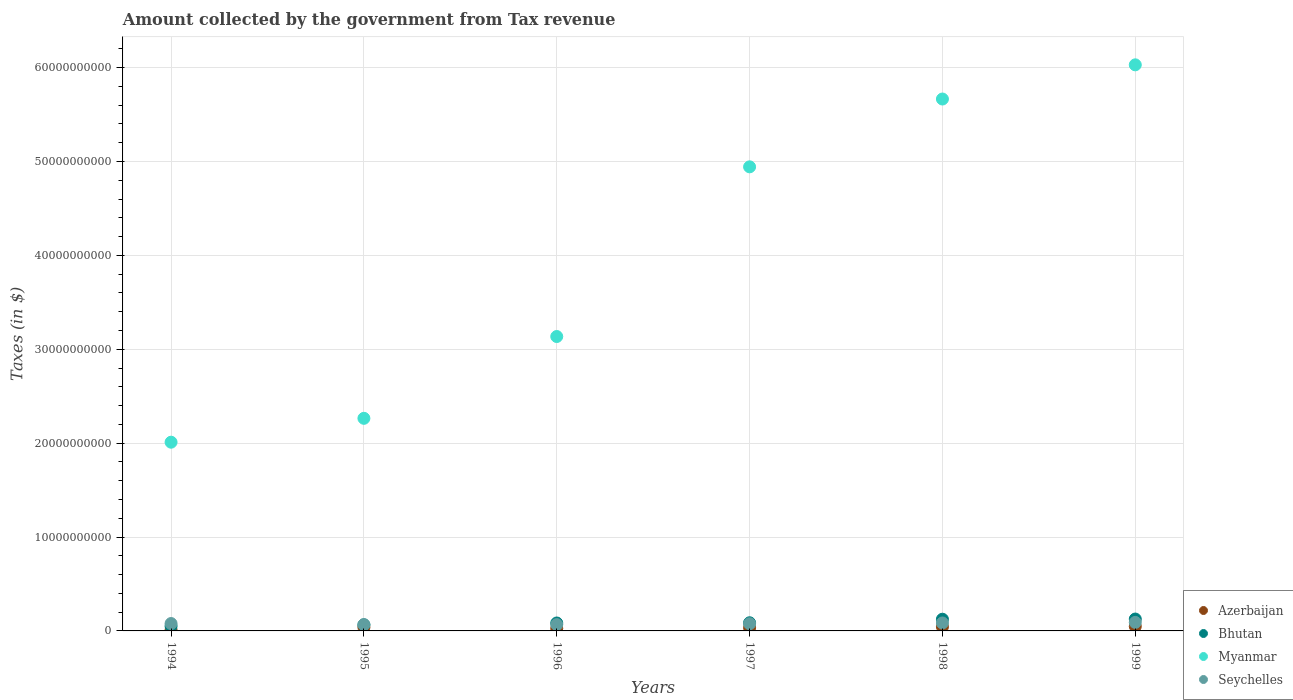What is the amount collected by the government from tax revenue in Bhutan in 1994?
Provide a succinct answer. 5.03e+08. Across all years, what is the maximum amount collected by the government from tax revenue in Bhutan?
Ensure brevity in your answer.  1.27e+09. Across all years, what is the minimum amount collected by the government from tax revenue in Bhutan?
Make the answer very short. 5.03e+08. What is the total amount collected by the government from tax revenue in Azerbaijan in the graph?
Offer a very short reply. 2.00e+09. What is the difference between the amount collected by the government from tax revenue in Myanmar in 1994 and that in 1999?
Keep it short and to the point. -4.02e+1. What is the difference between the amount collected by the government from tax revenue in Bhutan in 1997 and the amount collected by the government from tax revenue in Azerbaijan in 1999?
Provide a succinct answer. 3.88e+08. What is the average amount collected by the government from tax revenue in Myanmar per year?
Ensure brevity in your answer.  4.01e+1. In the year 1997, what is the difference between the amount collected by the government from tax revenue in Azerbaijan and amount collected by the government from tax revenue in Myanmar?
Provide a short and direct response. -4.91e+1. In how many years, is the amount collected by the government from tax revenue in Seychelles greater than 46000000000 $?
Your answer should be compact. 0. What is the ratio of the amount collected by the government from tax revenue in Myanmar in 1994 to that in 1998?
Make the answer very short. 0.35. Is the difference between the amount collected by the government from tax revenue in Azerbaijan in 1995 and 1998 greater than the difference between the amount collected by the government from tax revenue in Myanmar in 1995 and 1998?
Your answer should be compact. Yes. What is the difference between the highest and the second highest amount collected by the government from tax revenue in Myanmar?
Provide a succinct answer. 3.64e+09. What is the difference between the highest and the lowest amount collected by the government from tax revenue in Bhutan?
Offer a terse response. 7.62e+08. In how many years, is the amount collected by the government from tax revenue in Bhutan greater than the average amount collected by the government from tax revenue in Bhutan taken over all years?
Keep it short and to the point. 2. Is it the case that in every year, the sum of the amount collected by the government from tax revenue in Myanmar and amount collected by the government from tax revenue in Azerbaijan  is greater than the sum of amount collected by the government from tax revenue in Bhutan and amount collected by the government from tax revenue in Seychelles?
Make the answer very short. No. Is it the case that in every year, the sum of the amount collected by the government from tax revenue in Azerbaijan and amount collected by the government from tax revenue in Myanmar  is greater than the amount collected by the government from tax revenue in Seychelles?
Provide a succinct answer. Yes. Does the amount collected by the government from tax revenue in Azerbaijan monotonically increase over the years?
Offer a very short reply. No. Is the amount collected by the government from tax revenue in Myanmar strictly less than the amount collected by the government from tax revenue in Bhutan over the years?
Make the answer very short. No. How many years are there in the graph?
Offer a very short reply. 6. Does the graph contain grids?
Keep it short and to the point. Yes. Where does the legend appear in the graph?
Offer a very short reply. Bottom right. How many legend labels are there?
Offer a terse response. 4. How are the legend labels stacked?
Give a very brief answer. Vertical. What is the title of the graph?
Make the answer very short. Amount collected by the government from Tax revenue. What is the label or title of the X-axis?
Offer a very short reply. Years. What is the label or title of the Y-axis?
Provide a short and direct response. Taxes (in $). What is the Taxes (in $) of Azerbaijan in 1994?
Provide a short and direct response. 9.58e+07. What is the Taxes (in $) in Bhutan in 1994?
Make the answer very short. 5.03e+08. What is the Taxes (in $) in Myanmar in 1994?
Ensure brevity in your answer.  2.01e+1. What is the Taxes (in $) in Seychelles in 1994?
Give a very brief answer. 7.86e+08. What is the Taxes (in $) of Azerbaijan in 1995?
Offer a terse response. 3.83e+08. What is the Taxes (in $) of Bhutan in 1995?
Your response must be concise. 6.50e+08. What is the Taxes (in $) in Myanmar in 1995?
Ensure brevity in your answer.  2.26e+1. What is the Taxes (in $) in Seychelles in 1995?
Offer a terse response. 6.69e+08. What is the Taxes (in $) in Azerbaijan in 1996?
Make the answer very short. 2.69e+08. What is the Taxes (in $) in Bhutan in 1996?
Make the answer very short. 8.44e+08. What is the Taxes (in $) of Myanmar in 1996?
Your response must be concise. 3.14e+1. What is the Taxes (in $) in Seychelles in 1996?
Offer a terse response. 6.74e+08. What is the Taxes (in $) of Azerbaijan in 1997?
Make the answer very short. 3.38e+08. What is the Taxes (in $) of Bhutan in 1997?
Your answer should be compact. 8.69e+08. What is the Taxes (in $) in Myanmar in 1997?
Make the answer very short. 4.94e+1. What is the Taxes (in $) of Seychelles in 1997?
Make the answer very short. 7.63e+08. What is the Taxes (in $) in Azerbaijan in 1998?
Offer a terse response. 4.36e+08. What is the Taxes (in $) of Bhutan in 1998?
Provide a short and direct response. 1.25e+09. What is the Taxes (in $) of Myanmar in 1998?
Provide a succinct answer. 5.67e+1. What is the Taxes (in $) of Seychelles in 1998?
Your response must be concise. 8.46e+08. What is the Taxes (in $) of Azerbaijan in 1999?
Keep it short and to the point. 4.81e+08. What is the Taxes (in $) of Bhutan in 1999?
Make the answer very short. 1.27e+09. What is the Taxes (in $) in Myanmar in 1999?
Offer a terse response. 6.03e+1. What is the Taxes (in $) of Seychelles in 1999?
Provide a short and direct response. 9.06e+08. Across all years, what is the maximum Taxes (in $) in Azerbaijan?
Keep it short and to the point. 4.81e+08. Across all years, what is the maximum Taxes (in $) in Bhutan?
Your answer should be very brief. 1.27e+09. Across all years, what is the maximum Taxes (in $) in Myanmar?
Keep it short and to the point. 6.03e+1. Across all years, what is the maximum Taxes (in $) in Seychelles?
Your answer should be compact. 9.06e+08. Across all years, what is the minimum Taxes (in $) of Azerbaijan?
Ensure brevity in your answer.  9.58e+07. Across all years, what is the minimum Taxes (in $) in Bhutan?
Offer a very short reply. 5.03e+08. Across all years, what is the minimum Taxes (in $) in Myanmar?
Your answer should be very brief. 2.01e+1. Across all years, what is the minimum Taxes (in $) of Seychelles?
Ensure brevity in your answer.  6.69e+08. What is the total Taxes (in $) in Azerbaijan in the graph?
Keep it short and to the point. 2.00e+09. What is the total Taxes (in $) in Bhutan in the graph?
Make the answer very short. 5.38e+09. What is the total Taxes (in $) in Myanmar in the graph?
Your response must be concise. 2.40e+11. What is the total Taxes (in $) of Seychelles in the graph?
Provide a short and direct response. 4.64e+09. What is the difference between the Taxes (in $) of Azerbaijan in 1994 and that in 1995?
Offer a very short reply. -2.87e+08. What is the difference between the Taxes (in $) in Bhutan in 1994 and that in 1995?
Make the answer very short. -1.46e+08. What is the difference between the Taxes (in $) of Myanmar in 1994 and that in 1995?
Your answer should be very brief. -2.54e+09. What is the difference between the Taxes (in $) in Seychelles in 1994 and that in 1995?
Make the answer very short. 1.17e+08. What is the difference between the Taxes (in $) in Azerbaijan in 1994 and that in 1996?
Keep it short and to the point. -1.73e+08. What is the difference between the Taxes (in $) in Bhutan in 1994 and that in 1996?
Make the answer very short. -3.41e+08. What is the difference between the Taxes (in $) of Myanmar in 1994 and that in 1996?
Provide a short and direct response. -1.13e+1. What is the difference between the Taxes (in $) of Seychelles in 1994 and that in 1996?
Ensure brevity in your answer.  1.13e+08. What is the difference between the Taxes (in $) of Azerbaijan in 1994 and that in 1997?
Your answer should be compact. -2.42e+08. What is the difference between the Taxes (in $) in Bhutan in 1994 and that in 1997?
Provide a succinct answer. -3.66e+08. What is the difference between the Taxes (in $) in Myanmar in 1994 and that in 1997?
Your answer should be very brief. -2.93e+1. What is the difference between the Taxes (in $) in Seychelles in 1994 and that in 1997?
Provide a succinct answer. 2.32e+07. What is the difference between the Taxes (in $) of Azerbaijan in 1994 and that in 1998?
Make the answer very short. -3.40e+08. What is the difference between the Taxes (in $) of Bhutan in 1994 and that in 1998?
Your answer should be compact. -7.43e+08. What is the difference between the Taxes (in $) of Myanmar in 1994 and that in 1998?
Offer a terse response. -3.66e+1. What is the difference between the Taxes (in $) in Seychelles in 1994 and that in 1998?
Your response must be concise. -6.01e+07. What is the difference between the Taxes (in $) in Azerbaijan in 1994 and that in 1999?
Ensure brevity in your answer.  -3.85e+08. What is the difference between the Taxes (in $) in Bhutan in 1994 and that in 1999?
Your answer should be compact. -7.62e+08. What is the difference between the Taxes (in $) of Myanmar in 1994 and that in 1999?
Ensure brevity in your answer.  -4.02e+1. What is the difference between the Taxes (in $) in Seychelles in 1994 and that in 1999?
Your response must be concise. -1.20e+08. What is the difference between the Taxes (in $) in Azerbaijan in 1995 and that in 1996?
Your answer should be compact. 1.14e+08. What is the difference between the Taxes (in $) of Bhutan in 1995 and that in 1996?
Your answer should be very brief. -1.94e+08. What is the difference between the Taxes (in $) of Myanmar in 1995 and that in 1996?
Offer a very short reply. -8.71e+09. What is the difference between the Taxes (in $) in Seychelles in 1995 and that in 1996?
Your answer should be compact. -4.70e+06. What is the difference between the Taxes (in $) of Azerbaijan in 1995 and that in 1997?
Provide a short and direct response. 4.54e+07. What is the difference between the Taxes (in $) in Bhutan in 1995 and that in 1997?
Your response must be concise. -2.19e+08. What is the difference between the Taxes (in $) of Myanmar in 1995 and that in 1997?
Offer a terse response. -2.68e+1. What is the difference between the Taxes (in $) in Seychelles in 1995 and that in 1997?
Make the answer very short. -9.42e+07. What is the difference between the Taxes (in $) of Azerbaijan in 1995 and that in 1998?
Give a very brief answer. -5.31e+07. What is the difference between the Taxes (in $) of Bhutan in 1995 and that in 1998?
Make the answer very short. -5.97e+08. What is the difference between the Taxes (in $) in Myanmar in 1995 and that in 1998?
Give a very brief answer. -3.40e+1. What is the difference between the Taxes (in $) of Seychelles in 1995 and that in 1998?
Your answer should be very brief. -1.78e+08. What is the difference between the Taxes (in $) in Azerbaijan in 1995 and that in 1999?
Your answer should be compact. -9.76e+07. What is the difference between the Taxes (in $) in Bhutan in 1995 and that in 1999?
Your answer should be compact. -6.16e+08. What is the difference between the Taxes (in $) in Myanmar in 1995 and that in 1999?
Make the answer very short. -3.76e+1. What is the difference between the Taxes (in $) in Seychelles in 1995 and that in 1999?
Make the answer very short. -2.37e+08. What is the difference between the Taxes (in $) of Azerbaijan in 1996 and that in 1997?
Offer a terse response. -6.86e+07. What is the difference between the Taxes (in $) in Bhutan in 1996 and that in 1997?
Make the answer very short. -2.47e+07. What is the difference between the Taxes (in $) of Myanmar in 1996 and that in 1997?
Ensure brevity in your answer.  -1.81e+1. What is the difference between the Taxes (in $) of Seychelles in 1996 and that in 1997?
Keep it short and to the point. -8.95e+07. What is the difference between the Taxes (in $) of Azerbaijan in 1996 and that in 1998?
Your answer should be very brief. -1.67e+08. What is the difference between the Taxes (in $) in Bhutan in 1996 and that in 1998?
Your answer should be very brief. -4.02e+08. What is the difference between the Taxes (in $) of Myanmar in 1996 and that in 1998?
Your answer should be very brief. -2.53e+1. What is the difference between the Taxes (in $) of Seychelles in 1996 and that in 1998?
Provide a succinct answer. -1.73e+08. What is the difference between the Taxes (in $) in Azerbaijan in 1996 and that in 1999?
Ensure brevity in your answer.  -2.12e+08. What is the difference between the Taxes (in $) of Bhutan in 1996 and that in 1999?
Ensure brevity in your answer.  -4.22e+08. What is the difference between the Taxes (in $) in Myanmar in 1996 and that in 1999?
Your response must be concise. -2.89e+1. What is the difference between the Taxes (in $) of Seychelles in 1996 and that in 1999?
Provide a succinct answer. -2.32e+08. What is the difference between the Taxes (in $) in Azerbaijan in 1997 and that in 1998?
Provide a succinct answer. -9.85e+07. What is the difference between the Taxes (in $) of Bhutan in 1997 and that in 1998?
Provide a succinct answer. -3.77e+08. What is the difference between the Taxes (in $) of Myanmar in 1997 and that in 1998?
Your answer should be compact. -7.22e+09. What is the difference between the Taxes (in $) of Seychelles in 1997 and that in 1998?
Ensure brevity in your answer.  -8.33e+07. What is the difference between the Taxes (in $) in Azerbaijan in 1997 and that in 1999?
Provide a short and direct response. -1.43e+08. What is the difference between the Taxes (in $) of Bhutan in 1997 and that in 1999?
Ensure brevity in your answer.  -3.97e+08. What is the difference between the Taxes (in $) of Myanmar in 1997 and that in 1999?
Provide a succinct answer. -1.09e+1. What is the difference between the Taxes (in $) of Seychelles in 1997 and that in 1999?
Provide a succinct answer. -1.43e+08. What is the difference between the Taxes (in $) in Azerbaijan in 1998 and that in 1999?
Ensure brevity in your answer.  -4.45e+07. What is the difference between the Taxes (in $) in Bhutan in 1998 and that in 1999?
Your answer should be compact. -1.94e+07. What is the difference between the Taxes (in $) in Myanmar in 1998 and that in 1999?
Make the answer very short. -3.64e+09. What is the difference between the Taxes (in $) of Seychelles in 1998 and that in 1999?
Provide a succinct answer. -5.96e+07. What is the difference between the Taxes (in $) in Azerbaijan in 1994 and the Taxes (in $) in Bhutan in 1995?
Your answer should be compact. -5.54e+08. What is the difference between the Taxes (in $) in Azerbaijan in 1994 and the Taxes (in $) in Myanmar in 1995?
Offer a terse response. -2.25e+1. What is the difference between the Taxes (in $) in Azerbaijan in 1994 and the Taxes (in $) in Seychelles in 1995?
Give a very brief answer. -5.73e+08. What is the difference between the Taxes (in $) in Bhutan in 1994 and the Taxes (in $) in Myanmar in 1995?
Your response must be concise. -2.21e+1. What is the difference between the Taxes (in $) of Bhutan in 1994 and the Taxes (in $) of Seychelles in 1995?
Offer a very short reply. -1.66e+08. What is the difference between the Taxes (in $) in Myanmar in 1994 and the Taxes (in $) in Seychelles in 1995?
Your response must be concise. 1.94e+1. What is the difference between the Taxes (in $) of Azerbaijan in 1994 and the Taxes (in $) of Bhutan in 1996?
Your answer should be compact. -7.48e+08. What is the difference between the Taxes (in $) in Azerbaijan in 1994 and the Taxes (in $) in Myanmar in 1996?
Offer a terse response. -3.13e+1. What is the difference between the Taxes (in $) in Azerbaijan in 1994 and the Taxes (in $) in Seychelles in 1996?
Provide a succinct answer. -5.78e+08. What is the difference between the Taxes (in $) in Bhutan in 1994 and the Taxes (in $) in Myanmar in 1996?
Offer a very short reply. -3.09e+1. What is the difference between the Taxes (in $) of Bhutan in 1994 and the Taxes (in $) of Seychelles in 1996?
Provide a succinct answer. -1.70e+08. What is the difference between the Taxes (in $) of Myanmar in 1994 and the Taxes (in $) of Seychelles in 1996?
Keep it short and to the point. 1.94e+1. What is the difference between the Taxes (in $) in Azerbaijan in 1994 and the Taxes (in $) in Bhutan in 1997?
Provide a short and direct response. -7.73e+08. What is the difference between the Taxes (in $) of Azerbaijan in 1994 and the Taxes (in $) of Myanmar in 1997?
Keep it short and to the point. -4.93e+1. What is the difference between the Taxes (in $) of Azerbaijan in 1994 and the Taxes (in $) of Seychelles in 1997?
Your answer should be very brief. -6.67e+08. What is the difference between the Taxes (in $) in Bhutan in 1994 and the Taxes (in $) in Myanmar in 1997?
Your answer should be compact. -4.89e+1. What is the difference between the Taxes (in $) of Bhutan in 1994 and the Taxes (in $) of Seychelles in 1997?
Provide a succinct answer. -2.60e+08. What is the difference between the Taxes (in $) in Myanmar in 1994 and the Taxes (in $) in Seychelles in 1997?
Ensure brevity in your answer.  1.93e+1. What is the difference between the Taxes (in $) in Azerbaijan in 1994 and the Taxes (in $) in Bhutan in 1998?
Your answer should be very brief. -1.15e+09. What is the difference between the Taxes (in $) of Azerbaijan in 1994 and the Taxes (in $) of Myanmar in 1998?
Give a very brief answer. -5.66e+1. What is the difference between the Taxes (in $) of Azerbaijan in 1994 and the Taxes (in $) of Seychelles in 1998?
Your answer should be very brief. -7.51e+08. What is the difference between the Taxes (in $) of Bhutan in 1994 and the Taxes (in $) of Myanmar in 1998?
Your response must be concise. -5.61e+1. What is the difference between the Taxes (in $) of Bhutan in 1994 and the Taxes (in $) of Seychelles in 1998?
Keep it short and to the point. -3.43e+08. What is the difference between the Taxes (in $) in Myanmar in 1994 and the Taxes (in $) in Seychelles in 1998?
Your answer should be very brief. 1.93e+1. What is the difference between the Taxes (in $) in Azerbaijan in 1994 and the Taxes (in $) in Bhutan in 1999?
Offer a very short reply. -1.17e+09. What is the difference between the Taxes (in $) in Azerbaijan in 1994 and the Taxes (in $) in Myanmar in 1999?
Make the answer very short. -6.02e+1. What is the difference between the Taxes (in $) of Azerbaijan in 1994 and the Taxes (in $) of Seychelles in 1999?
Provide a succinct answer. -8.10e+08. What is the difference between the Taxes (in $) in Bhutan in 1994 and the Taxes (in $) in Myanmar in 1999?
Your response must be concise. -5.98e+1. What is the difference between the Taxes (in $) of Bhutan in 1994 and the Taxes (in $) of Seychelles in 1999?
Offer a terse response. -4.03e+08. What is the difference between the Taxes (in $) of Myanmar in 1994 and the Taxes (in $) of Seychelles in 1999?
Give a very brief answer. 1.92e+1. What is the difference between the Taxes (in $) in Azerbaijan in 1995 and the Taxes (in $) in Bhutan in 1996?
Make the answer very short. -4.61e+08. What is the difference between the Taxes (in $) of Azerbaijan in 1995 and the Taxes (in $) of Myanmar in 1996?
Provide a succinct answer. -3.10e+1. What is the difference between the Taxes (in $) of Azerbaijan in 1995 and the Taxes (in $) of Seychelles in 1996?
Offer a very short reply. -2.90e+08. What is the difference between the Taxes (in $) in Bhutan in 1995 and the Taxes (in $) in Myanmar in 1996?
Keep it short and to the point. -3.07e+1. What is the difference between the Taxes (in $) of Bhutan in 1995 and the Taxes (in $) of Seychelles in 1996?
Provide a short and direct response. -2.37e+07. What is the difference between the Taxes (in $) of Myanmar in 1995 and the Taxes (in $) of Seychelles in 1996?
Ensure brevity in your answer.  2.20e+1. What is the difference between the Taxes (in $) of Azerbaijan in 1995 and the Taxes (in $) of Bhutan in 1997?
Provide a succinct answer. -4.86e+08. What is the difference between the Taxes (in $) of Azerbaijan in 1995 and the Taxes (in $) of Myanmar in 1997?
Make the answer very short. -4.90e+1. What is the difference between the Taxes (in $) in Azerbaijan in 1995 and the Taxes (in $) in Seychelles in 1997?
Keep it short and to the point. -3.80e+08. What is the difference between the Taxes (in $) in Bhutan in 1995 and the Taxes (in $) in Myanmar in 1997?
Your response must be concise. -4.88e+1. What is the difference between the Taxes (in $) in Bhutan in 1995 and the Taxes (in $) in Seychelles in 1997?
Your answer should be compact. -1.13e+08. What is the difference between the Taxes (in $) in Myanmar in 1995 and the Taxes (in $) in Seychelles in 1997?
Make the answer very short. 2.19e+1. What is the difference between the Taxes (in $) of Azerbaijan in 1995 and the Taxes (in $) of Bhutan in 1998?
Make the answer very short. -8.63e+08. What is the difference between the Taxes (in $) of Azerbaijan in 1995 and the Taxes (in $) of Myanmar in 1998?
Provide a succinct answer. -5.63e+1. What is the difference between the Taxes (in $) of Azerbaijan in 1995 and the Taxes (in $) of Seychelles in 1998?
Offer a very short reply. -4.63e+08. What is the difference between the Taxes (in $) of Bhutan in 1995 and the Taxes (in $) of Myanmar in 1998?
Ensure brevity in your answer.  -5.60e+1. What is the difference between the Taxes (in $) in Bhutan in 1995 and the Taxes (in $) in Seychelles in 1998?
Provide a short and direct response. -1.96e+08. What is the difference between the Taxes (in $) of Myanmar in 1995 and the Taxes (in $) of Seychelles in 1998?
Keep it short and to the point. 2.18e+1. What is the difference between the Taxes (in $) of Azerbaijan in 1995 and the Taxes (in $) of Bhutan in 1999?
Ensure brevity in your answer.  -8.83e+08. What is the difference between the Taxes (in $) in Azerbaijan in 1995 and the Taxes (in $) in Myanmar in 1999?
Your response must be concise. -5.99e+1. What is the difference between the Taxes (in $) of Azerbaijan in 1995 and the Taxes (in $) of Seychelles in 1999?
Provide a succinct answer. -5.23e+08. What is the difference between the Taxes (in $) in Bhutan in 1995 and the Taxes (in $) in Myanmar in 1999?
Make the answer very short. -5.96e+1. What is the difference between the Taxes (in $) of Bhutan in 1995 and the Taxes (in $) of Seychelles in 1999?
Offer a terse response. -2.56e+08. What is the difference between the Taxes (in $) in Myanmar in 1995 and the Taxes (in $) in Seychelles in 1999?
Ensure brevity in your answer.  2.17e+1. What is the difference between the Taxes (in $) in Azerbaijan in 1996 and the Taxes (in $) in Bhutan in 1997?
Offer a very short reply. -6.00e+08. What is the difference between the Taxes (in $) in Azerbaijan in 1996 and the Taxes (in $) in Myanmar in 1997?
Your answer should be compact. -4.92e+1. What is the difference between the Taxes (in $) of Azerbaijan in 1996 and the Taxes (in $) of Seychelles in 1997?
Provide a short and direct response. -4.94e+08. What is the difference between the Taxes (in $) in Bhutan in 1996 and the Taxes (in $) in Myanmar in 1997?
Ensure brevity in your answer.  -4.86e+1. What is the difference between the Taxes (in $) in Bhutan in 1996 and the Taxes (in $) in Seychelles in 1997?
Provide a short and direct response. 8.12e+07. What is the difference between the Taxes (in $) in Myanmar in 1996 and the Taxes (in $) in Seychelles in 1997?
Offer a very short reply. 3.06e+1. What is the difference between the Taxes (in $) in Azerbaijan in 1996 and the Taxes (in $) in Bhutan in 1998?
Keep it short and to the point. -9.77e+08. What is the difference between the Taxes (in $) in Azerbaijan in 1996 and the Taxes (in $) in Myanmar in 1998?
Provide a succinct answer. -5.64e+1. What is the difference between the Taxes (in $) in Azerbaijan in 1996 and the Taxes (in $) in Seychelles in 1998?
Provide a short and direct response. -5.77e+08. What is the difference between the Taxes (in $) in Bhutan in 1996 and the Taxes (in $) in Myanmar in 1998?
Your response must be concise. -5.58e+1. What is the difference between the Taxes (in $) in Bhutan in 1996 and the Taxes (in $) in Seychelles in 1998?
Keep it short and to the point. -2.10e+06. What is the difference between the Taxes (in $) in Myanmar in 1996 and the Taxes (in $) in Seychelles in 1998?
Give a very brief answer. 3.05e+1. What is the difference between the Taxes (in $) in Azerbaijan in 1996 and the Taxes (in $) in Bhutan in 1999?
Provide a short and direct response. -9.97e+08. What is the difference between the Taxes (in $) in Azerbaijan in 1996 and the Taxes (in $) in Myanmar in 1999?
Keep it short and to the point. -6.00e+1. What is the difference between the Taxes (in $) in Azerbaijan in 1996 and the Taxes (in $) in Seychelles in 1999?
Give a very brief answer. -6.37e+08. What is the difference between the Taxes (in $) in Bhutan in 1996 and the Taxes (in $) in Myanmar in 1999?
Offer a very short reply. -5.94e+1. What is the difference between the Taxes (in $) of Bhutan in 1996 and the Taxes (in $) of Seychelles in 1999?
Offer a very short reply. -6.17e+07. What is the difference between the Taxes (in $) in Myanmar in 1996 and the Taxes (in $) in Seychelles in 1999?
Provide a short and direct response. 3.05e+1. What is the difference between the Taxes (in $) in Azerbaijan in 1997 and the Taxes (in $) in Bhutan in 1998?
Provide a short and direct response. -9.09e+08. What is the difference between the Taxes (in $) of Azerbaijan in 1997 and the Taxes (in $) of Myanmar in 1998?
Your response must be concise. -5.63e+1. What is the difference between the Taxes (in $) in Azerbaijan in 1997 and the Taxes (in $) in Seychelles in 1998?
Your answer should be very brief. -5.09e+08. What is the difference between the Taxes (in $) of Bhutan in 1997 and the Taxes (in $) of Myanmar in 1998?
Provide a short and direct response. -5.58e+1. What is the difference between the Taxes (in $) in Bhutan in 1997 and the Taxes (in $) in Seychelles in 1998?
Provide a short and direct response. 2.26e+07. What is the difference between the Taxes (in $) in Myanmar in 1997 and the Taxes (in $) in Seychelles in 1998?
Offer a very short reply. 4.86e+1. What is the difference between the Taxes (in $) of Azerbaijan in 1997 and the Taxes (in $) of Bhutan in 1999?
Ensure brevity in your answer.  -9.28e+08. What is the difference between the Taxes (in $) in Azerbaijan in 1997 and the Taxes (in $) in Myanmar in 1999?
Keep it short and to the point. -6.00e+1. What is the difference between the Taxes (in $) in Azerbaijan in 1997 and the Taxes (in $) in Seychelles in 1999?
Make the answer very short. -5.68e+08. What is the difference between the Taxes (in $) in Bhutan in 1997 and the Taxes (in $) in Myanmar in 1999?
Offer a terse response. -5.94e+1. What is the difference between the Taxes (in $) of Bhutan in 1997 and the Taxes (in $) of Seychelles in 1999?
Offer a very short reply. -3.70e+07. What is the difference between the Taxes (in $) of Myanmar in 1997 and the Taxes (in $) of Seychelles in 1999?
Offer a very short reply. 4.85e+1. What is the difference between the Taxes (in $) of Azerbaijan in 1998 and the Taxes (in $) of Bhutan in 1999?
Your answer should be compact. -8.30e+08. What is the difference between the Taxes (in $) in Azerbaijan in 1998 and the Taxes (in $) in Myanmar in 1999?
Your response must be concise. -5.99e+1. What is the difference between the Taxes (in $) in Azerbaijan in 1998 and the Taxes (in $) in Seychelles in 1999?
Give a very brief answer. -4.70e+08. What is the difference between the Taxes (in $) in Bhutan in 1998 and the Taxes (in $) in Myanmar in 1999?
Provide a short and direct response. -5.90e+1. What is the difference between the Taxes (in $) of Bhutan in 1998 and the Taxes (in $) of Seychelles in 1999?
Your answer should be very brief. 3.40e+08. What is the difference between the Taxes (in $) of Myanmar in 1998 and the Taxes (in $) of Seychelles in 1999?
Offer a terse response. 5.57e+1. What is the average Taxes (in $) in Azerbaijan per year?
Offer a terse response. 3.34e+08. What is the average Taxes (in $) in Bhutan per year?
Your answer should be very brief. 8.96e+08. What is the average Taxes (in $) in Myanmar per year?
Offer a very short reply. 4.01e+1. What is the average Taxes (in $) of Seychelles per year?
Provide a short and direct response. 7.74e+08. In the year 1994, what is the difference between the Taxes (in $) in Azerbaijan and Taxes (in $) in Bhutan?
Give a very brief answer. -4.08e+08. In the year 1994, what is the difference between the Taxes (in $) of Azerbaijan and Taxes (in $) of Myanmar?
Your answer should be compact. -2.00e+1. In the year 1994, what is the difference between the Taxes (in $) in Azerbaijan and Taxes (in $) in Seychelles?
Your response must be concise. -6.90e+08. In the year 1994, what is the difference between the Taxes (in $) in Bhutan and Taxes (in $) in Myanmar?
Ensure brevity in your answer.  -1.96e+1. In the year 1994, what is the difference between the Taxes (in $) of Bhutan and Taxes (in $) of Seychelles?
Make the answer very short. -2.83e+08. In the year 1994, what is the difference between the Taxes (in $) of Myanmar and Taxes (in $) of Seychelles?
Your answer should be compact. 1.93e+1. In the year 1995, what is the difference between the Taxes (in $) of Azerbaijan and Taxes (in $) of Bhutan?
Offer a very short reply. -2.67e+08. In the year 1995, what is the difference between the Taxes (in $) in Azerbaijan and Taxes (in $) in Myanmar?
Your answer should be compact. -2.23e+1. In the year 1995, what is the difference between the Taxes (in $) of Azerbaijan and Taxes (in $) of Seychelles?
Your answer should be compact. -2.86e+08. In the year 1995, what is the difference between the Taxes (in $) in Bhutan and Taxes (in $) in Myanmar?
Provide a short and direct response. -2.20e+1. In the year 1995, what is the difference between the Taxes (in $) in Bhutan and Taxes (in $) in Seychelles?
Give a very brief answer. -1.90e+07. In the year 1995, what is the difference between the Taxes (in $) in Myanmar and Taxes (in $) in Seychelles?
Provide a succinct answer. 2.20e+1. In the year 1996, what is the difference between the Taxes (in $) of Azerbaijan and Taxes (in $) of Bhutan?
Your answer should be compact. -5.75e+08. In the year 1996, what is the difference between the Taxes (in $) of Azerbaijan and Taxes (in $) of Myanmar?
Your response must be concise. -3.11e+1. In the year 1996, what is the difference between the Taxes (in $) of Azerbaijan and Taxes (in $) of Seychelles?
Provide a short and direct response. -4.04e+08. In the year 1996, what is the difference between the Taxes (in $) of Bhutan and Taxes (in $) of Myanmar?
Offer a terse response. -3.05e+1. In the year 1996, what is the difference between the Taxes (in $) of Bhutan and Taxes (in $) of Seychelles?
Give a very brief answer. 1.71e+08. In the year 1996, what is the difference between the Taxes (in $) in Myanmar and Taxes (in $) in Seychelles?
Offer a very short reply. 3.07e+1. In the year 1997, what is the difference between the Taxes (in $) in Azerbaijan and Taxes (in $) in Bhutan?
Offer a terse response. -5.31e+08. In the year 1997, what is the difference between the Taxes (in $) of Azerbaijan and Taxes (in $) of Myanmar?
Offer a very short reply. -4.91e+1. In the year 1997, what is the difference between the Taxes (in $) in Azerbaijan and Taxes (in $) in Seychelles?
Offer a terse response. -4.25e+08. In the year 1997, what is the difference between the Taxes (in $) in Bhutan and Taxes (in $) in Myanmar?
Make the answer very short. -4.86e+1. In the year 1997, what is the difference between the Taxes (in $) of Bhutan and Taxes (in $) of Seychelles?
Your response must be concise. 1.06e+08. In the year 1997, what is the difference between the Taxes (in $) in Myanmar and Taxes (in $) in Seychelles?
Your answer should be compact. 4.87e+1. In the year 1998, what is the difference between the Taxes (in $) in Azerbaijan and Taxes (in $) in Bhutan?
Ensure brevity in your answer.  -8.10e+08. In the year 1998, what is the difference between the Taxes (in $) in Azerbaijan and Taxes (in $) in Myanmar?
Your response must be concise. -5.62e+1. In the year 1998, what is the difference between the Taxes (in $) of Azerbaijan and Taxes (in $) of Seychelles?
Keep it short and to the point. -4.10e+08. In the year 1998, what is the difference between the Taxes (in $) in Bhutan and Taxes (in $) in Myanmar?
Make the answer very short. -5.54e+1. In the year 1998, what is the difference between the Taxes (in $) of Bhutan and Taxes (in $) of Seychelles?
Your response must be concise. 4.00e+08. In the year 1998, what is the difference between the Taxes (in $) in Myanmar and Taxes (in $) in Seychelles?
Give a very brief answer. 5.58e+1. In the year 1999, what is the difference between the Taxes (in $) of Azerbaijan and Taxes (in $) of Bhutan?
Your answer should be compact. -7.85e+08. In the year 1999, what is the difference between the Taxes (in $) of Azerbaijan and Taxes (in $) of Myanmar?
Your response must be concise. -5.98e+1. In the year 1999, what is the difference between the Taxes (in $) in Azerbaijan and Taxes (in $) in Seychelles?
Keep it short and to the point. -4.25e+08. In the year 1999, what is the difference between the Taxes (in $) in Bhutan and Taxes (in $) in Myanmar?
Ensure brevity in your answer.  -5.90e+1. In the year 1999, what is the difference between the Taxes (in $) of Bhutan and Taxes (in $) of Seychelles?
Offer a terse response. 3.60e+08. In the year 1999, what is the difference between the Taxes (in $) in Myanmar and Taxes (in $) in Seychelles?
Your response must be concise. 5.94e+1. What is the ratio of the Taxes (in $) of Azerbaijan in 1994 to that in 1995?
Keep it short and to the point. 0.25. What is the ratio of the Taxes (in $) of Bhutan in 1994 to that in 1995?
Your answer should be very brief. 0.77. What is the ratio of the Taxes (in $) in Myanmar in 1994 to that in 1995?
Provide a succinct answer. 0.89. What is the ratio of the Taxes (in $) in Seychelles in 1994 to that in 1995?
Offer a terse response. 1.18. What is the ratio of the Taxes (in $) in Azerbaijan in 1994 to that in 1996?
Ensure brevity in your answer.  0.36. What is the ratio of the Taxes (in $) in Bhutan in 1994 to that in 1996?
Your answer should be compact. 0.6. What is the ratio of the Taxes (in $) of Myanmar in 1994 to that in 1996?
Provide a succinct answer. 0.64. What is the ratio of the Taxes (in $) in Seychelles in 1994 to that in 1996?
Provide a succinct answer. 1.17. What is the ratio of the Taxes (in $) of Azerbaijan in 1994 to that in 1997?
Offer a very short reply. 0.28. What is the ratio of the Taxes (in $) of Bhutan in 1994 to that in 1997?
Offer a very short reply. 0.58. What is the ratio of the Taxes (in $) of Myanmar in 1994 to that in 1997?
Provide a succinct answer. 0.41. What is the ratio of the Taxes (in $) of Seychelles in 1994 to that in 1997?
Provide a short and direct response. 1.03. What is the ratio of the Taxes (in $) in Azerbaijan in 1994 to that in 1998?
Your answer should be compact. 0.22. What is the ratio of the Taxes (in $) of Bhutan in 1994 to that in 1998?
Give a very brief answer. 0.4. What is the ratio of the Taxes (in $) of Myanmar in 1994 to that in 1998?
Give a very brief answer. 0.35. What is the ratio of the Taxes (in $) in Seychelles in 1994 to that in 1998?
Keep it short and to the point. 0.93. What is the ratio of the Taxes (in $) of Azerbaijan in 1994 to that in 1999?
Keep it short and to the point. 0.2. What is the ratio of the Taxes (in $) in Bhutan in 1994 to that in 1999?
Offer a terse response. 0.4. What is the ratio of the Taxes (in $) in Myanmar in 1994 to that in 1999?
Make the answer very short. 0.33. What is the ratio of the Taxes (in $) of Seychelles in 1994 to that in 1999?
Provide a succinct answer. 0.87. What is the ratio of the Taxes (in $) of Azerbaijan in 1995 to that in 1996?
Ensure brevity in your answer.  1.42. What is the ratio of the Taxes (in $) in Bhutan in 1995 to that in 1996?
Your answer should be very brief. 0.77. What is the ratio of the Taxes (in $) in Myanmar in 1995 to that in 1996?
Your response must be concise. 0.72. What is the ratio of the Taxes (in $) in Azerbaijan in 1995 to that in 1997?
Your answer should be compact. 1.13. What is the ratio of the Taxes (in $) of Bhutan in 1995 to that in 1997?
Offer a terse response. 0.75. What is the ratio of the Taxes (in $) in Myanmar in 1995 to that in 1997?
Provide a short and direct response. 0.46. What is the ratio of the Taxes (in $) of Seychelles in 1995 to that in 1997?
Ensure brevity in your answer.  0.88. What is the ratio of the Taxes (in $) in Azerbaijan in 1995 to that in 1998?
Give a very brief answer. 0.88. What is the ratio of the Taxes (in $) in Bhutan in 1995 to that in 1998?
Give a very brief answer. 0.52. What is the ratio of the Taxes (in $) in Myanmar in 1995 to that in 1998?
Make the answer very short. 0.4. What is the ratio of the Taxes (in $) in Seychelles in 1995 to that in 1998?
Your answer should be very brief. 0.79. What is the ratio of the Taxes (in $) of Azerbaijan in 1995 to that in 1999?
Make the answer very short. 0.8. What is the ratio of the Taxes (in $) in Bhutan in 1995 to that in 1999?
Provide a short and direct response. 0.51. What is the ratio of the Taxes (in $) in Myanmar in 1995 to that in 1999?
Offer a terse response. 0.38. What is the ratio of the Taxes (in $) of Seychelles in 1995 to that in 1999?
Your answer should be compact. 0.74. What is the ratio of the Taxes (in $) of Azerbaijan in 1996 to that in 1997?
Your response must be concise. 0.8. What is the ratio of the Taxes (in $) of Bhutan in 1996 to that in 1997?
Your response must be concise. 0.97. What is the ratio of the Taxes (in $) of Myanmar in 1996 to that in 1997?
Ensure brevity in your answer.  0.63. What is the ratio of the Taxes (in $) of Seychelles in 1996 to that in 1997?
Make the answer very short. 0.88. What is the ratio of the Taxes (in $) of Azerbaijan in 1996 to that in 1998?
Your response must be concise. 0.62. What is the ratio of the Taxes (in $) of Bhutan in 1996 to that in 1998?
Make the answer very short. 0.68. What is the ratio of the Taxes (in $) of Myanmar in 1996 to that in 1998?
Your response must be concise. 0.55. What is the ratio of the Taxes (in $) of Seychelles in 1996 to that in 1998?
Keep it short and to the point. 0.8. What is the ratio of the Taxes (in $) of Azerbaijan in 1996 to that in 1999?
Make the answer very short. 0.56. What is the ratio of the Taxes (in $) of Bhutan in 1996 to that in 1999?
Provide a short and direct response. 0.67. What is the ratio of the Taxes (in $) in Myanmar in 1996 to that in 1999?
Provide a succinct answer. 0.52. What is the ratio of the Taxes (in $) in Seychelles in 1996 to that in 1999?
Your response must be concise. 0.74. What is the ratio of the Taxes (in $) of Azerbaijan in 1997 to that in 1998?
Give a very brief answer. 0.77. What is the ratio of the Taxes (in $) of Bhutan in 1997 to that in 1998?
Keep it short and to the point. 0.7. What is the ratio of the Taxes (in $) of Myanmar in 1997 to that in 1998?
Give a very brief answer. 0.87. What is the ratio of the Taxes (in $) of Seychelles in 1997 to that in 1998?
Give a very brief answer. 0.9. What is the ratio of the Taxes (in $) in Azerbaijan in 1997 to that in 1999?
Your answer should be compact. 0.7. What is the ratio of the Taxes (in $) of Bhutan in 1997 to that in 1999?
Your response must be concise. 0.69. What is the ratio of the Taxes (in $) of Myanmar in 1997 to that in 1999?
Provide a succinct answer. 0.82. What is the ratio of the Taxes (in $) in Seychelles in 1997 to that in 1999?
Make the answer very short. 0.84. What is the ratio of the Taxes (in $) of Azerbaijan in 1998 to that in 1999?
Make the answer very short. 0.91. What is the ratio of the Taxes (in $) of Bhutan in 1998 to that in 1999?
Give a very brief answer. 0.98. What is the ratio of the Taxes (in $) in Myanmar in 1998 to that in 1999?
Ensure brevity in your answer.  0.94. What is the ratio of the Taxes (in $) of Seychelles in 1998 to that in 1999?
Your response must be concise. 0.93. What is the difference between the highest and the second highest Taxes (in $) in Azerbaijan?
Make the answer very short. 4.45e+07. What is the difference between the highest and the second highest Taxes (in $) of Bhutan?
Give a very brief answer. 1.94e+07. What is the difference between the highest and the second highest Taxes (in $) of Myanmar?
Offer a very short reply. 3.64e+09. What is the difference between the highest and the second highest Taxes (in $) in Seychelles?
Offer a very short reply. 5.96e+07. What is the difference between the highest and the lowest Taxes (in $) in Azerbaijan?
Your answer should be very brief. 3.85e+08. What is the difference between the highest and the lowest Taxes (in $) in Bhutan?
Your response must be concise. 7.62e+08. What is the difference between the highest and the lowest Taxes (in $) of Myanmar?
Your response must be concise. 4.02e+1. What is the difference between the highest and the lowest Taxes (in $) of Seychelles?
Your answer should be compact. 2.37e+08. 